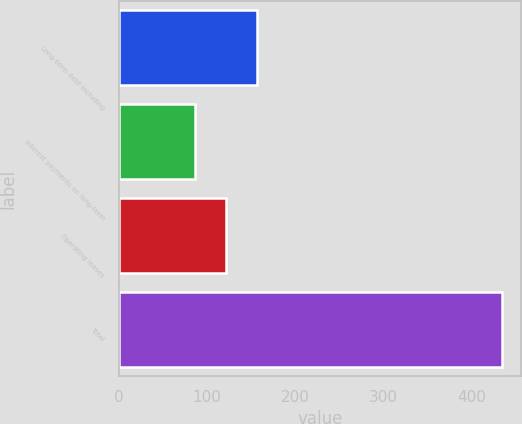Convert chart to OTSL. <chart><loc_0><loc_0><loc_500><loc_500><bar_chart><fcel>Long-term debt including<fcel>Interest payments on long-term<fcel>Operating leases<fcel>Total<nl><fcel>156.44<fcel>87.1<fcel>121.77<fcel>433.8<nl></chart> 